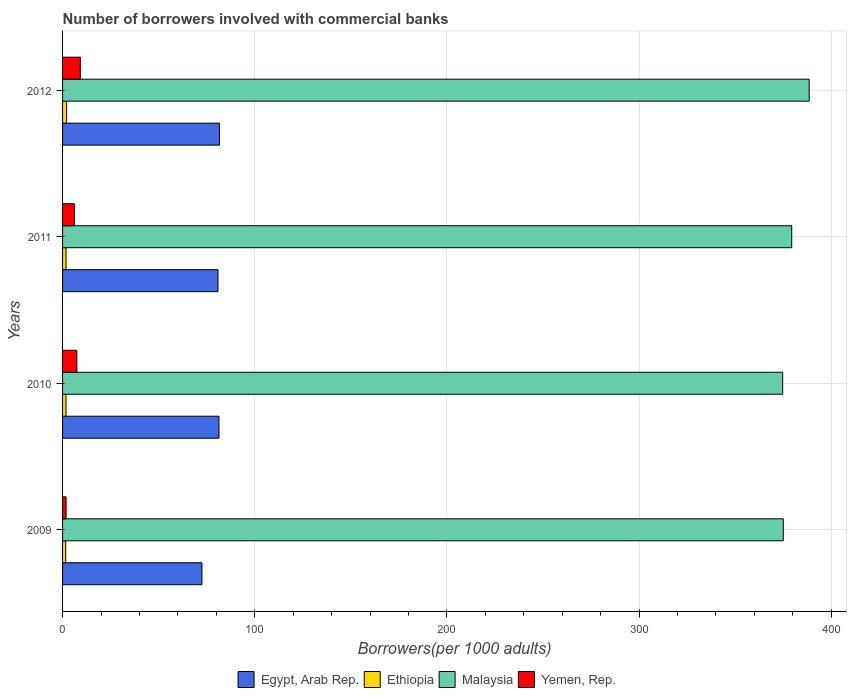How many different coloured bars are there?
Keep it short and to the point. 4. Are the number of bars on each tick of the Y-axis equal?
Offer a very short reply. Yes. What is the label of the 4th group of bars from the top?
Make the answer very short. 2009. In how many cases, is the number of bars for a given year not equal to the number of legend labels?
Keep it short and to the point. 0. What is the number of borrowers involved with commercial banks in Malaysia in 2011?
Your answer should be compact. 379.42. Across all years, what is the maximum number of borrowers involved with commercial banks in Egypt, Arab Rep.?
Ensure brevity in your answer.  81.61. Across all years, what is the minimum number of borrowers involved with commercial banks in Malaysia?
Provide a short and direct response. 374.71. In which year was the number of borrowers involved with commercial banks in Yemen, Rep. maximum?
Ensure brevity in your answer.  2012. What is the total number of borrowers involved with commercial banks in Malaysia in the graph?
Your response must be concise. 1517.65. What is the difference between the number of borrowers involved with commercial banks in Yemen, Rep. in 2010 and that in 2011?
Provide a short and direct response. 1.29. What is the difference between the number of borrowers involved with commercial banks in Egypt, Arab Rep. in 2009 and the number of borrowers involved with commercial banks in Yemen, Rep. in 2012?
Provide a succinct answer. 63.29. What is the average number of borrowers involved with commercial banks in Malaysia per year?
Keep it short and to the point. 379.41. In the year 2011, what is the difference between the number of borrowers involved with commercial banks in Malaysia and number of borrowers involved with commercial banks in Egypt, Arab Rep.?
Provide a succinct answer. 298.55. In how many years, is the number of borrowers involved with commercial banks in Malaysia greater than 320 ?
Offer a terse response. 4. What is the ratio of the number of borrowers involved with commercial banks in Egypt, Arab Rep. in 2010 to that in 2012?
Your response must be concise. 1. What is the difference between the highest and the second highest number of borrowers involved with commercial banks in Ethiopia?
Your response must be concise. 0.3. What is the difference between the highest and the lowest number of borrowers involved with commercial banks in Ethiopia?
Make the answer very short. 0.45. Is the sum of the number of borrowers involved with commercial banks in Yemen, Rep. in 2009 and 2012 greater than the maximum number of borrowers involved with commercial banks in Egypt, Arab Rep. across all years?
Keep it short and to the point. No. What does the 3rd bar from the top in 2012 represents?
Your answer should be very brief. Ethiopia. What does the 3rd bar from the bottom in 2012 represents?
Provide a succinct answer. Malaysia. How many bars are there?
Keep it short and to the point. 16. How many years are there in the graph?
Offer a very short reply. 4. Does the graph contain any zero values?
Provide a succinct answer. No. What is the title of the graph?
Provide a short and direct response. Number of borrowers involved with commercial banks. What is the label or title of the X-axis?
Offer a very short reply. Borrowers(per 1000 adults). What is the label or title of the Y-axis?
Make the answer very short. Years. What is the Borrowers(per 1000 adults) of Egypt, Arab Rep. in 2009?
Provide a short and direct response. 72.52. What is the Borrowers(per 1000 adults) in Ethiopia in 2009?
Ensure brevity in your answer.  1.65. What is the Borrowers(per 1000 adults) in Malaysia in 2009?
Ensure brevity in your answer.  375.03. What is the Borrowers(per 1000 adults) in Yemen, Rep. in 2009?
Your answer should be very brief. 1.83. What is the Borrowers(per 1000 adults) of Egypt, Arab Rep. in 2010?
Offer a terse response. 81.39. What is the Borrowers(per 1000 adults) of Ethiopia in 2010?
Offer a terse response. 1.78. What is the Borrowers(per 1000 adults) of Malaysia in 2010?
Provide a succinct answer. 374.71. What is the Borrowers(per 1000 adults) of Yemen, Rep. in 2010?
Provide a short and direct response. 7.43. What is the Borrowers(per 1000 adults) of Egypt, Arab Rep. in 2011?
Your answer should be very brief. 80.87. What is the Borrowers(per 1000 adults) of Ethiopia in 2011?
Your response must be concise. 1.81. What is the Borrowers(per 1000 adults) of Malaysia in 2011?
Provide a short and direct response. 379.42. What is the Borrowers(per 1000 adults) in Yemen, Rep. in 2011?
Your answer should be very brief. 6.14. What is the Borrowers(per 1000 adults) of Egypt, Arab Rep. in 2012?
Your answer should be compact. 81.61. What is the Borrowers(per 1000 adults) in Ethiopia in 2012?
Your answer should be compact. 2.1. What is the Borrowers(per 1000 adults) in Malaysia in 2012?
Ensure brevity in your answer.  388.49. What is the Borrowers(per 1000 adults) of Yemen, Rep. in 2012?
Make the answer very short. 9.23. Across all years, what is the maximum Borrowers(per 1000 adults) in Egypt, Arab Rep.?
Your answer should be compact. 81.61. Across all years, what is the maximum Borrowers(per 1000 adults) of Ethiopia?
Offer a very short reply. 2.1. Across all years, what is the maximum Borrowers(per 1000 adults) in Malaysia?
Keep it short and to the point. 388.49. Across all years, what is the maximum Borrowers(per 1000 adults) in Yemen, Rep.?
Your answer should be compact. 9.23. Across all years, what is the minimum Borrowers(per 1000 adults) of Egypt, Arab Rep.?
Your answer should be very brief. 72.52. Across all years, what is the minimum Borrowers(per 1000 adults) in Ethiopia?
Your response must be concise. 1.65. Across all years, what is the minimum Borrowers(per 1000 adults) in Malaysia?
Give a very brief answer. 374.71. Across all years, what is the minimum Borrowers(per 1000 adults) of Yemen, Rep.?
Offer a terse response. 1.83. What is the total Borrowers(per 1000 adults) in Egypt, Arab Rep. in the graph?
Offer a very short reply. 316.38. What is the total Borrowers(per 1000 adults) of Ethiopia in the graph?
Your response must be concise. 7.35. What is the total Borrowers(per 1000 adults) in Malaysia in the graph?
Provide a succinct answer. 1517.65. What is the total Borrowers(per 1000 adults) in Yemen, Rep. in the graph?
Make the answer very short. 24.63. What is the difference between the Borrowers(per 1000 adults) in Egypt, Arab Rep. in 2009 and that in 2010?
Keep it short and to the point. -8.87. What is the difference between the Borrowers(per 1000 adults) in Ethiopia in 2009 and that in 2010?
Ensure brevity in your answer.  -0.13. What is the difference between the Borrowers(per 1000 adults) in Malaysia in 2009 and that in 2010?
Your answer should be compact. 0.32. What is the difference between the Borrowers(per 1000 adults) of Yemen, Rep. in 2009 and that in 2010?
Offer a very short reply. -5.6. What is the difference between the Borrowers(per 1000 adults) in Egypt, Arab Rep. in 2009 and that in 2011?
Your answer should be very brief. -8.35. What is the difference between the Borrowers(per 1000 adults) of Ethiopia in 2009 and that in 2011?
Give a very brief answer. -0.16. What is the difference between the Borrowers(per 1000 adults) of Malaysia in 2009 and that in 2011?
Your answer should be very brief. -4.39. What is the difference between the Borrowers(per 1000 adults) in Yemen, Rep. in 2009 and that in 2011?
Ensure brevity in your answer.  -4.32. What is the difference between the Borrowers(per 1000 adults) of Egypt, Arab Rep. in 2009 and that in 2012?
Provide a succinct answer. -9.09. What is the difference between the Borrowers(per 1000 adults) in Ethiopia in 2009 and that in 2012?
Keep it short and to the point. -0.45. What is the difference between the Borrowers(per 1000 adults) in Malaysia in 2009 and that in 2012?
Give a very brief answer. -13.46. What is the difference between the Borrowers(per 1000 adults) of Yemen, Rep. in 2009 and that in 2012?
Make the answer very short. -7.41. What is the difference between the Borrowers(per 1000 adults) in Egypt, Arab Rep. in 2010 and that in 2011?
Offer a very short reply. 0.52. What is the difference between the Borrowers(per 1000 adults) of Ethiopia in 2010 and that in 2011?
Keep it short and to the point. -0.02. What is the difference between the Borrowers(per 1000 adults) of Malaysia in 2010 and that in 2011?
Offer a terse response. -4.71. What is the difference between the Borrowers(per 1000 adults) in Yemen, Rep. in 2010 and that in 2011?
Offer a terse response. 1.29. What is the difference between the Borrowers(per 1000 adults) of Egypt, Arab Rep. in 2010 and that in 2012?
Make the answer very short. -0.21. What is the difference between the Borrowers(per 1000 adults) in Ethiopia in 2010 and that in 2012?
Ensure brevity in your answer.  -0.32. What is the difference between the Borrowers(per 1000 adults) in Malaysia in 2010 and that in 2012?
Provide a succinct answer. -13.78. What is the difference between the Borrowers(per 1000 adults) of Yemen, Rep. in 2010 and that in 2012?
Make the answer very short. -1.8. What is the difference between the Borrowers(per 1000 adults) in Egypt, Arab Rep. in 2011 and that in 2012?
Make the answer very short. -0.74. What is the difference between the Borrowers(per 1000 adults) in Ethiopia in 2011 and that in 2012?
Your answer should be compact. -0.3. What is the difference between the Borrowers(per 1000 adults) in Malaysia in 2011 and that in 2012?
Offer a terse response. -9.07. What is the difference between the Borrowers(per 1000 adults) in Yemen, Rep. in 2011 and that in 2012?
Offer a very short reply. -3.09. What is the difference between the Borrowers(per 1000 adults) of Egypt, Arab Rep. in 2009 and the Borrowers(per 1000 adults) of Ethiopia in 2010?
Make the answer very short. 70.73. What is the difference between the Borrowers(per 1000 adults) in Egypt, Arab Rep. in 2009 and the Borrowers(per 1000 adults) in Malaysia in 2010?
Your answer should be compact. -302.19. What is the difference between the Borrowers(per 1000 adults) of Egypt, Arab Rep. in 2009 and the Borrowers(per 1000 adults) of Yemen, Rep. in 2010?
Keep it short and to the point. 65.09. What is the difference between the Borrowers(per 1000 adults) of Ethiopia in 2009 and the Borrowers(per 1000 adults) of Malaysia in 2010?
Your answer should be compact. -373.06. What is the difference between the Borrowers(per 1000 adults) in Ethiopia in 2009 and the Borrowers(per 1000 adults) in Yemen, Rep. in 2010?
Provide a short and direct response. -5.78. What is the difference between the Borrowers(per 1000 adults) of Malaysia in 2009 and the Borrowers(per 1000 adults) of Yemen, Rep. in 2010?
Your answer should be very brief. 367.6. What is the difference between the Borrowers(per 1000 adults) of Egypt, Arab Rep. in 2009 and the Borrowers(per 1000 adults) of Ethiopia in 2011?
Make the answer very short. 70.71. What is the difference between the Borrowers(per 1000 adults) in Egypt, Arab Rep. in 2009 and the Borrowers(per 1000 adults) in Malaysia in 2011?
Ensure brevity in your answer.  -306.9. What is the difference between the Borrowers(per 1000 adults) in Egypt, Arab Rep. in 2009 and the Borrowers(per 1000 adults) in Yemen, Rep. in 2011?
Give a very brief answer. 66.38. What is the difference between the Borrowers(per 1000 adults) of Ethiopia in 2009 and the Borrowers(per 1000 adults) of Malaysia in 2011?
Ensure brevity in your answer.  -377.77. What is the difference between the Borrowers(per 1000 adults) of Ethiopia in 2009 and the Borrowers(per 1000 adults) of Yemen, Rep. in 2011?
Give a very brief answer. -4.49. What is the difference between the Borrowers(per 1000 adults) of Malaysia in 2009 and the Borrowers(per 1000 adults) of Yemen, Rep. in 2011?
Your answer should be very brief. 368.89. What is the difference between the Borrowers(per 1000 adults) in Egypt, Arab Rep. in 2009 and the Borrowers(per 1000 adults) in Ethiopia in 2012?
Offer a terse response. 70.42. What is the difference between the Borrowers(per 1000 adults) in Egypt, Arab Rep. in 2009 and the Borrowers(per 1000 adults) in Malaysia in 2012?
Provide a short and direct response. -315.97. What is the difference between the Borrowers(per 1000 adults) of Egypt, Arab Rep. in 2009 and the Borrowers(per 1000 adults) of Yemen, Rep. in 2012?
Your response must be concise. 63.29. What is the difference between the Borrowers(per 1000 adults) of Ethiopia in 2009 and the Borrowers(per 1000 adults) of Malaysia in 2012?
Your answer should be compact. -386.84. What is the difference between the Borrowers(per 1000 adults) in Ethiopia in 2009 and the Borrowers(per 1000 adults) in Yemen, Rep. in 2012?
Ensure brevity in your answer.  -7.58. What is the difference between the Borrowers(per 1000 adults) of Malaysia in 2009 and the Borrowers(per 1000 adults) of Yemen, Rep. in 2012?
Provide a succinct answer. 365.8. What is the difference between the Borrowers(per 1000 adults) in Egypt, Arab Rep. in 2010 and the Borrowers(per 1000 adults) in Ethiopia in 2011?
Keep it short and to the point. 79.58. What is the difference between the Borrowers(per 1000 adults) in Egypt, Arab Rep. in 2010 and the Borrowers(per 1000 adults) in Malaysia in 2011?
Offer a very short reply. -298.03. What is the difference between the Borrowers(per 1000 adults) of Egypt, Arab Rep. in 2010 and the Borrowers(per 1000 adults) of Yemen, Rep. in 2011?
Keep it short and to the point. 75.25. What is the difference between the Borrowers(per 1000 adults) of Ethiopia in 2010 and the Borrowers(per 1000 adults) of Malaysia in 2011?
Offer a very short reply. -377.63. What is the difference between the Borrowers(per 1000 adults) of Ethiopia in 2010 and the Borrowers(per 1000 adults) of Yemen, Rep. in 2011?
Keep it short and to the point. -4.36. What is the difference between the Borrowers(per 1000 adults) of Malaysia in 2010 and the Borrowers(per 1000 adults) of Yemen, Rep. in 2011?
Ensure brevity in your answer.  368.57. What is the difference between the Borrowers(per 1000 adults) of Egypt, Arab Rep. in 2010 and the Borrowers(per 1000 adults) of Ethiopia in 2012?
Offer a very short reply. 79.29. What is the difference between the Borrowers(per 1000 adults) in Egypt, Arab Rep. in 2010 and the Borrowers(per 1000 adults) in Malaysia in 2012?
Make the answer very short. -307.1. What is the difference between the Borrowers(per 1000 adults) in Egypt, Arab Rep. in 2010 and the Borrowers(per 1000 adults) in Yemen, Rep. in 2012?
Keep it short and to the point. 72.16. What is the difference between the Borrowers(per 1000 adults) in Ethiopia in 2010 and the Borrowers(per 1000 adults) in Malaysia in 2012?
Offer a very short reply. -386.71. What is the difference between the Borrowers(per 1000 adults) in Ethiopia in 2010 and the Borrowers(per 1000 adults) in Yemen, Rep. in 2012?
Give a very brief answer. -7.45. What is the difference between the Borrowers(per 1000 adults) of Malaysia in 2010 and the Borrowers(per 1000 adults) of Yemen, Rep. in 2012?
Give a very brief answer. 365.48. What is the difference between the Borrowers(per 1000 adults) in Egypt, Arab Rep. in 2011 and the Borrowers(per 1000 adults) in Ethiopia in 2012?
Your answer should be very brief. 78.76. What is the difference between the Borrowers(per 1000 adults) in Egypt, Arab Rep. in 2011 and the Borrowers(per 1000 adults) in Malaysia in 2012?
Your answer should be very brief. -307.63. What is the difference between the Borrowers(per 1000 adults) of Egypt, Arab Rep. in 2011 and the Borrowers(per 1000 adults) of Yemen, Rep. in 2012?
Provide a short and direct response. 71.63. What is the difference between the Borrowers(per 1000 adults) of Ethiopia in 2011 and the Borrowers(per 1000 adults) of Malaysia in 2012?
Your answer should be very brief. -386.68. What is the difference between the Borrowers(per 1000 adults) in Ethiopia in 2011 and the Borrowers(per 1000 adults) in Yemen, Rep. in 2012?
Provide a succinct answer. -7.42. What is the difference between the Borrowers(per 1000 adults) in Malaysia in 2011 and the Borrowers(per 1000 adults) in Yemen, Rep. in 2012?
Offer a very short reply. 370.19. What is the average Borrowers(per 1000 adults) of Egypt, Arab Rep. per year?
Ensure brevity in your answer.  79.1. What is the average Borrowers(per 1000 adults) in Ethiopia per year?
Give a very brief answer. 1.84. What is the average Borrowers(per 1000 adults) in Malaysia per year?
Your answer should be compact. 379.41. What is the average Borrowers(per 1000 adults) in Yemen, Rep. per year?
Give a very brief answer. 6.16. In the year 2009, what is the difference between the Borrowers(per 1000 adults) of Egypt, Arab Rep. and Borrowers(per 1000 adults) of Ethiopia?
Your answer should be compact. 70.87. In the year 2009, what is the difference between the Borrowers(per 1000 adults) of Egypt, Arab Rep. and Borrowers(per 1000 adults) of Malaysia?
Your answer should be very brief. -302.51. In the year 2009, what is the difference between the Borrowers(per 1000 adults) in Egypt, Arab Rep. and Borrowers(per 1000 adults) in Yemen, Rep.?
Provide a short and direct response. 70.69. In the year 2009, what is the difference between the Borrowers(per 1000 adults) of Ethiopia and Borrowers(per 1000 adults) of Malaysia?
Your response must be concise. -373.38. In the year 2009, what is the difference between the Borrowers(per 1000 adults) in Ethiopia and Borrowers(per 1000 adults) in Yemen, Rep.?
Your answer should be compact. -0.18. In the year 2009, what is the difference between the Borrowers(per 1000 adults) of Malaysia and Borrowers(per 1000 adults) of Yemen, Rep.?
Make the answer very short. 373.2. In the year 2010, what is the difference between the Borrowers(per 1000 adults) in Egypt, Arab Rep. and Borrowers(per 1000 adults) in Ethiopia?
Your response must be concise. 79.61. In the year 2010, what is the difference between the Borrowers(per 1000 adults) in Egypt, Arab Rep. and Borrowers(per 1000 adults) in Malaysia?
Keep it short and to the point. -293.32. In the year 2010, what is the difference between the Borrowers(per 1000 adults) of Egypt, Arab Rep. and Borrowers(per 1000 adults) of Yemen, Rep.?
Offer a terse response. 73.96. In the year 2010, what is the difference between the Borrowers(per 1000 adults) in Ethiopia and Borrowers(per 1000 adults) in Malaysia?
Your answer should be compact. -372.93. In the year 2010, what is the difference between the Borrowers(per 1000 adults) of Ethiopia and Borrowers(per 1000 adults) of Yemen, Rep.?
Provide a short and direct response. -5.65. In the year 2010, what is the difference between the Borrowers(per 1000 adults) in Malaysia and Borrowers(per 1000 adults) in Yemen, Rep.?
Your answer should be compact. 367.28. In the year 2011, what is the difference between the Borrowers(per 1000 adults) of Egypt, Arab Rep. and Borrowers(per 1000 adults) of Ethiopia?
Provide a succinct answer. 79.06. In the year 2011, what is the difference between the Borrowers(per 1000 adults) of Egypt, Arab Rep. and Borrowers(per 1000 adults) of Malaysia?
Your answer should be very brief. -298.55. In the year 2011, what is the difference between the Borrowers(per 1000 adults) of Egypt, Arab Rep. and Borrowers(per 1000 adults) of Yemen, Rep.?
Make the answer very short. 74.72. In the year 2011, what is the difference between the Borrowers(per 1000 adults) in Ethiopia and Borrowers(per 1000 adults) in Malaysia?
Make the answer very short. -377.61. In the year 2011, what is the difference between the Borrowers(per 1000 adults) of Ethiopia and Borrowers(per 1000 adults) of Yemen, Rep.?
Give a very brief answer. -4.33. In the year 2011, what is the difference between the Borrowers(per 1000 adults) of Malaysia and Borrowers(per 1000 adults) of Yemen, Rep.?
Offer a very short reply. 373.28. In the year 2012, what is the difference between the Borrowers(per 1000 adults) in Egypt, Arab Rep. and Borrowers(per 1000 adults) in Ethiopia?
Your answer should be very brief. 79.5. In the year 2012, what is the difference between the Borrowers(per 1000 adults) of Egypt, Arab Rep. and Borrowers(per 1000 adults) of Malaysia?
Your answer should be very brief. -306.89. In the year 2012, what is the difference between the Borrowers(per 1000 adults) of Egypt, Arab Rep. and Borrowers(per 1000 adults) of Yemen, Rep.?
Provide a short and direct response. 72.37. In the year 2012, what is the difference between the Borrowers(per 1000 adults) in Ethiopia and Borrowers(per 1000 adults) in Malaysia?
Your answer should be compact. -386.39. In the year 2012, what is the difference between the Borrowers(per 1000 adults) of Ethiopia and Borrowers(per 1000 adults) of Yemen, Rep.?
Ensure brevity in your answer.  -7.13. In the year 2012, what is the difference between the Borrowers(per 1000 adults) of Malaysia and Borrowers(per 1000 adults) of Yemen, Rep.?
Offer a terse response. 379.26. What is the ratio of the Borrowers(per 1000 adults) of Egypt, Arab Rep. in 2009 to that in 2010?
Offer a very short reply. 0.89. What is the ratio of the Borrowers(per 1000 adults) of Ethiopia in 2009 to that in 2010?
Ensure brevity in your answer.  0.93. What is the ratio of the Borrowers(per 1000 adults) in Yemen, Rep. in 2009 to that in 2010?
Your answer should be very brief. 0.25. What is the ratio of the Borrowers(per 1000 adults) in Egypt, Arab Rep. in 2009 to that in 2011?
Ensure brevity in your answer.  0.9. What is the ratio of the Borrowers(per 1000 adults) of Ethiopia in 2009 to that in 2011?
Provide a short and direct response. 0.91. What is the ratio of the Borrowers(per 1000 adults) of Malaysia in 2009 to that in 2011?
Your answer should be compact. 0.99. What is the ratio of the Borrowers(per 1000 adults) of Yemen, Rep. in 2009 to that in 2011?
Your answer should be compact. 0.3. What is the ratio of the Borrowers(per 1000 adults) in Egypt, Arab Rep. in 2009 to that in 2012?
Make the answer very short. 0.89. What is the ratio of the Borrowers(per 1000 adults) of Ethiopia in 2009 to that in 2012?
Keep it short and to the point. 0.78. What is the ratio of the Borrowers(per 1000 adults) of Malaysia in 2009 to that in 2012?
Provide a short and direct response. 0.97. What is the ratio of the Borrowers(per 1000 adults) of Yemen, Rep. in 2009 to that in 2012?
Make the answer very short. 0.2. What is the ratio of the Borrowers(per 1000 adults) in Egypt, Arab Rep. in 2010 to that in 2011?
Your answer should be compact. 1.01. What is the ratio of the Borrowers(per 1000 adults) in Ethiopia in 2010 to that in 2011?
Make the answer very short. 0.99. What is the ratio of the Borrowers(per 1000 adults) of Malaysia in 2010 to that in 2011?
Provide a short and direct response. 0.99. What is the ratio of the Borrowers(per 1000 adults) in Yemen, Rep. in 2010 to that in 2011?
Your answer should be very brief. 1.21. What is the ratio of the Borrowers(per 1000 adults) in Ethiopia in 2010 to that in 2012?
Keep it short and to the point. 0.85. What is the ratio of the Borrowers(per 1000 adults) in Malaysia in 2010 to that in 2012?
Ensure brevity in your answer.  0.96. What is the ratio of the Borrowers(per 1000 adults) in Yemen, Rep. in 2010 to that in 2012?
Your response must be concise. 0.8. What is the ratio of the Borrowers(per 1000 adults) in Egypt, Arab Rep. in 2011 to that in 2012?
Offer a terse response. 0.99. What is the ratio of the Borrowers(per 1000 adults) of Ethiopia in 2011 to that in 2012?
Offer a terse response. 0.86. What is the ratio of the Borrowers(per 1000 adults) of Malaysia in 2011 to that in 2012?
Make the answer very short. 0.98. What is the ratio of the Borrowers(per 1000 adults) in Yemen, Rep. in 2011 to that in 2012?
Keep it short and to the point. 0.67. What is the difference between the highest and the second highest Borrowers(per 1000 adults) of Egypt, Arab Rep.?
Offer a very short reply. 0.21. What is the difference between the highest and the second highest Borrowers(per 1000 adults) in Ethiopia?
Your answer should be compact. 0.3. What is the difference between the highest and the second highest Borrowers(per 1000 adults) in Malaysia?
Your answer should be compact. 9.07. What is the difference between the highest and the second highest Borrowers(per 1000 adults) of Yemen, Rep.?
Offer a terse response. 1.8. What is the difference between the highest and the lowest Borrowers(per 1000 adults) in Egypt, Arab Rep.?
Provide a succinct answer. 9.09. What is the difference between the highest and the lowest Borrowers(per 1000 adults) of Ethiopia?
Your answer should be very brief. 0.45. What is the difference between the highest and the lowest Borrowers(per 1000 adults) in Malaysia?
Ensure brevity in your answer.  13.78. What is the difference between the highest and the lowest Borrowers(per 1000 adults) of Yemen, Rep.?
Give a very brief answer. 7.41. 